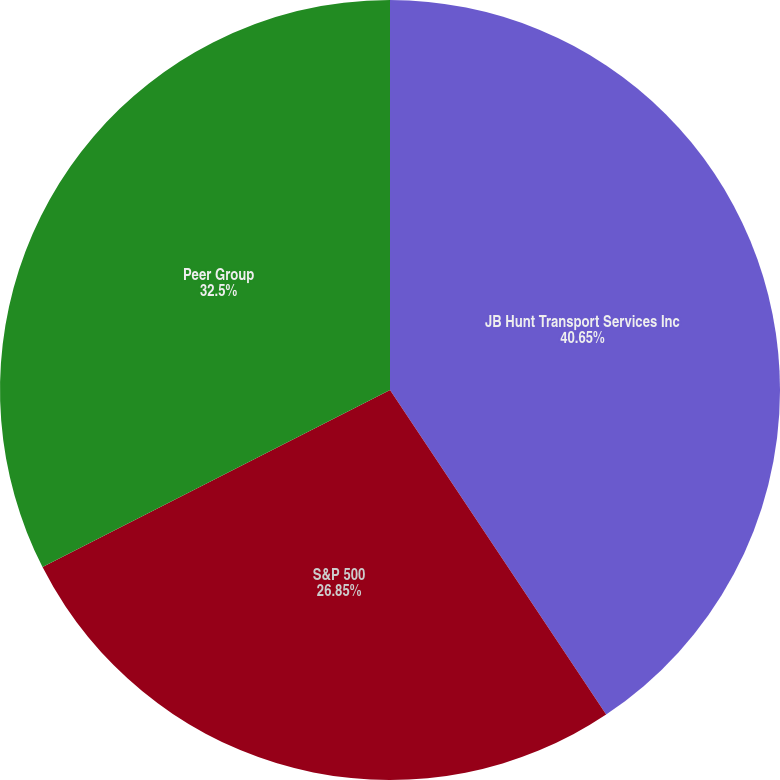Convert chart to OTSL. <chart><loc_0><loc_0><loc_500><loc_500><pie_chart><fcel>JB Hunt Transport Services Inc<fcel>S&P 500<fcel>Peer Group<nl><fcel>40.65%<fcel>26.85%<fcel>32.5%<nl></chart> 